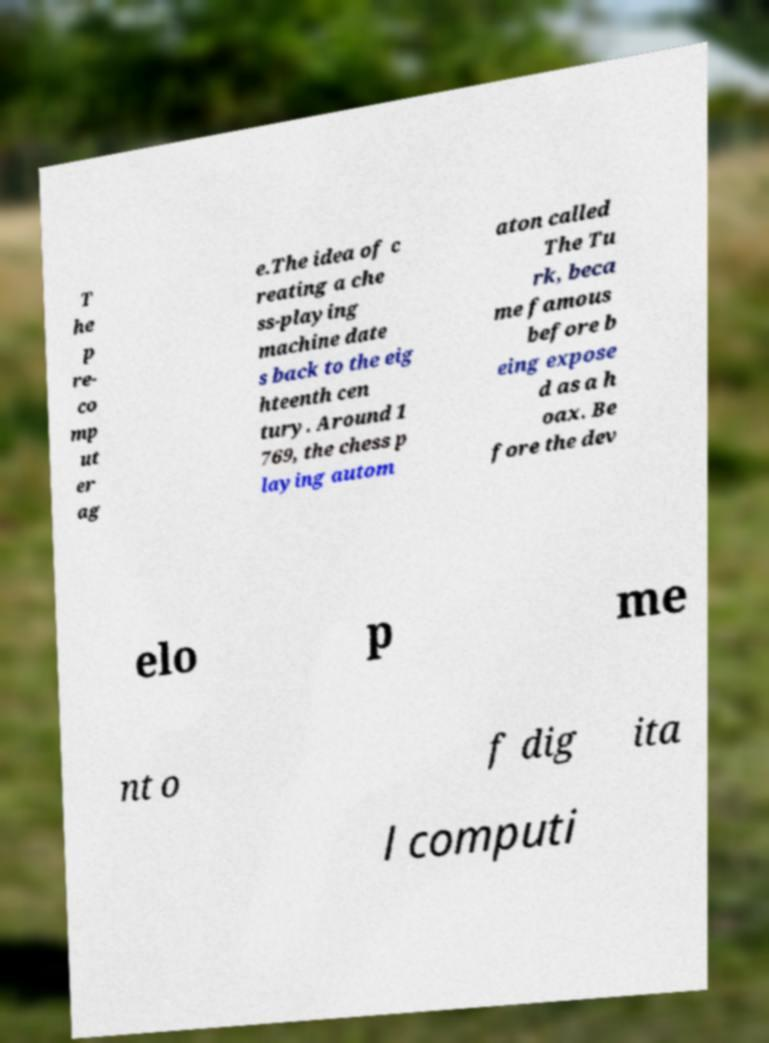For documentation purposes, I need the text within this image transcribed. Could you provide that? T he p re- co mp ut er ag e.The idea of c reating a che ss-playing machine date s back to the eig hteenth cen tury. Around 1 769, the chess p laying autom aton called The Tu rk, beca me famous before b eing expose d as a h oax. Be fore the dev elo p me nt o f dig ita l computi 